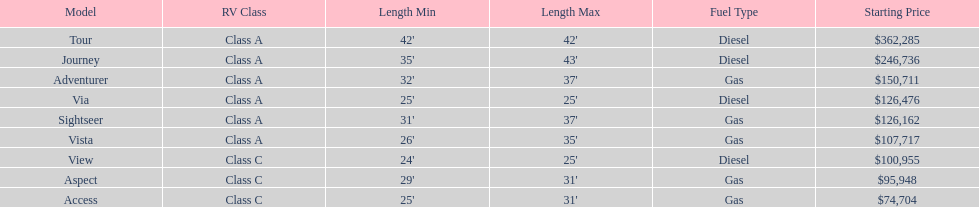What is the price of bot the via and tour models combined? $488,761. 